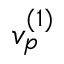Convert formula to latex. <formula><loc_0><loc_0><loc_500><loc_500>v _ { p } ^ { ( 1 ) }</formula> 